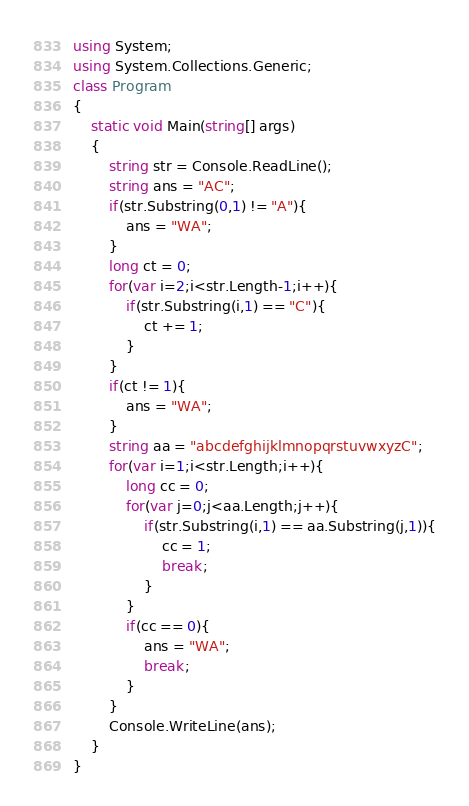Convert code to text. <code><loc_0><loc_0><loc_500><loc_500><_C#_>using System;
using System.Collections.Generic;
class Program
{
	static void Main(string[] args)
	{
		string str = Console.ReadLine();
		string ans = "AC";
		if(str.Substring(0,1) != "A"){
			ans = "WA";
		}
		long ct = 0;
		for(var i=2;i<str.Length-1;i++){
			if(str.Substring(i,1) == "C"){
				ct += 1;
			}
		}
		if(ct != 1){
			ans = "WA";
		}
		string aa = "abcdefghijklmnopqrstuvwxyzC";
		for(var i=1;i<str.Length;i++){
			long cc = 0;
			for(var j=0;j<aa.Length;j++){
				if(str.Substring(i,1) == aa.Substring(j,1)){
					cc = 1;
					break;
				}
			}
			if(cc == 0){
				ans = "WA";
				break;
			}
		}
		Console.WriteLine(ans);
	}
}</code> 